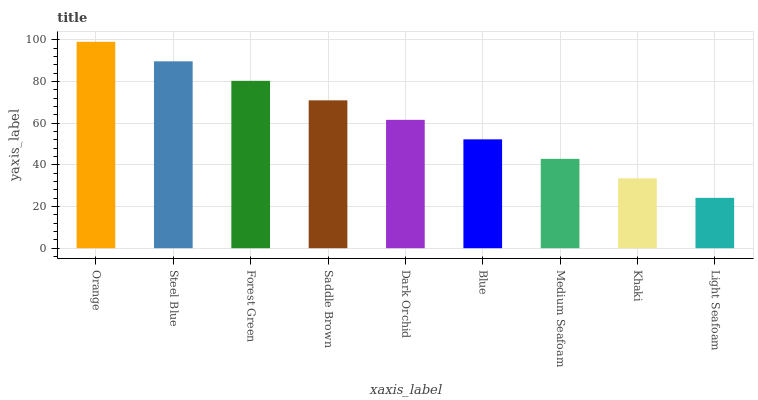Is Steel Blue the minimum?
Answer yes or no. No. Is Steel Blue the maximum?
Answer yes or no. No. Is Orange greater than Steel Blue?
Answer yes or no. Yes. Is Steel Blue less than Orange?
Answer yes or no. Yes. Is Steel Blue greater than Orange?
Answer yes or no. No. Is Orange less than Steel Blue?
Answer yes or no. No. Is Dark Orchid the high median?
Answer yes or no. Yes. Is Dark Orchid the low median?
Answer yes or no. Yes. Is Medium Seafoam the high median?
Answer yes or no. No. Is Khaki the low median?
Answer yes or no. No. 